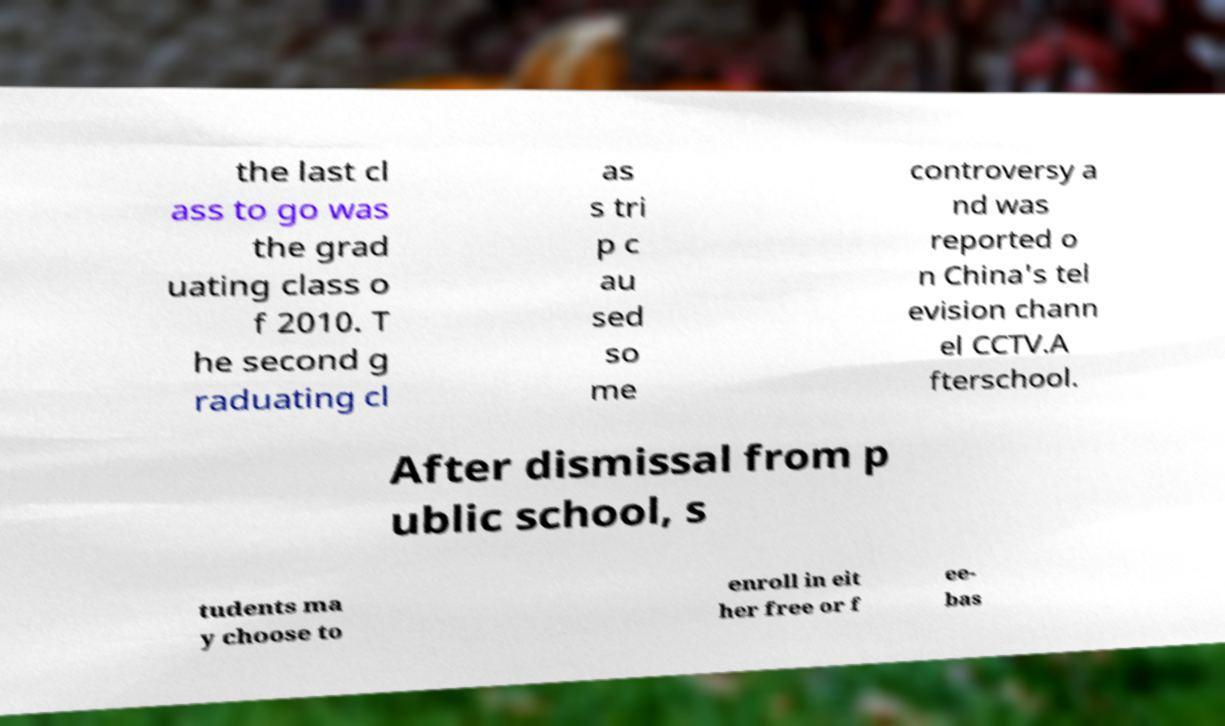For documentation purposes, I need the text within this image transcribed. Could you provide that? the last cl ass to go was the grad uating class o f 2010. T he second g raduating cl as s tri p c au sed so me controversy a nd was reported o n China's tel evision chann el CCTV.A fterschool. After dismissal from p ublic school, s tudents ma y choose to enroll in eit her free or f ee- bas 